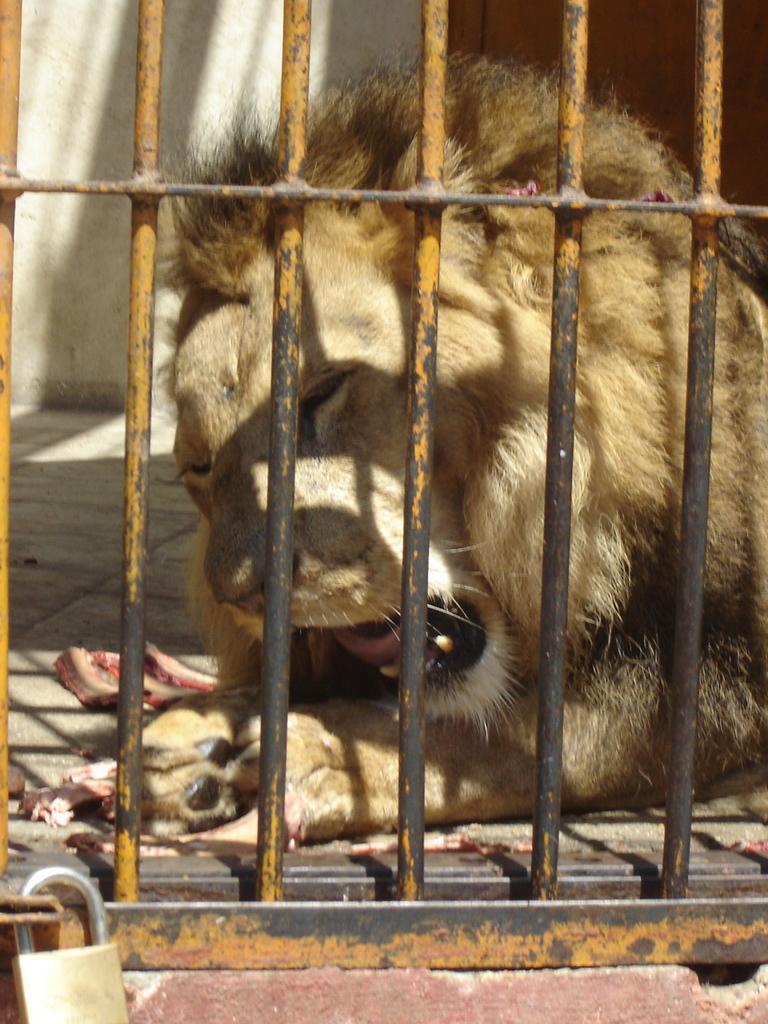Can you describe this image briefly? In this image I can see the cage and the lock. Inside the cage I can see the lion which is in brown color. 